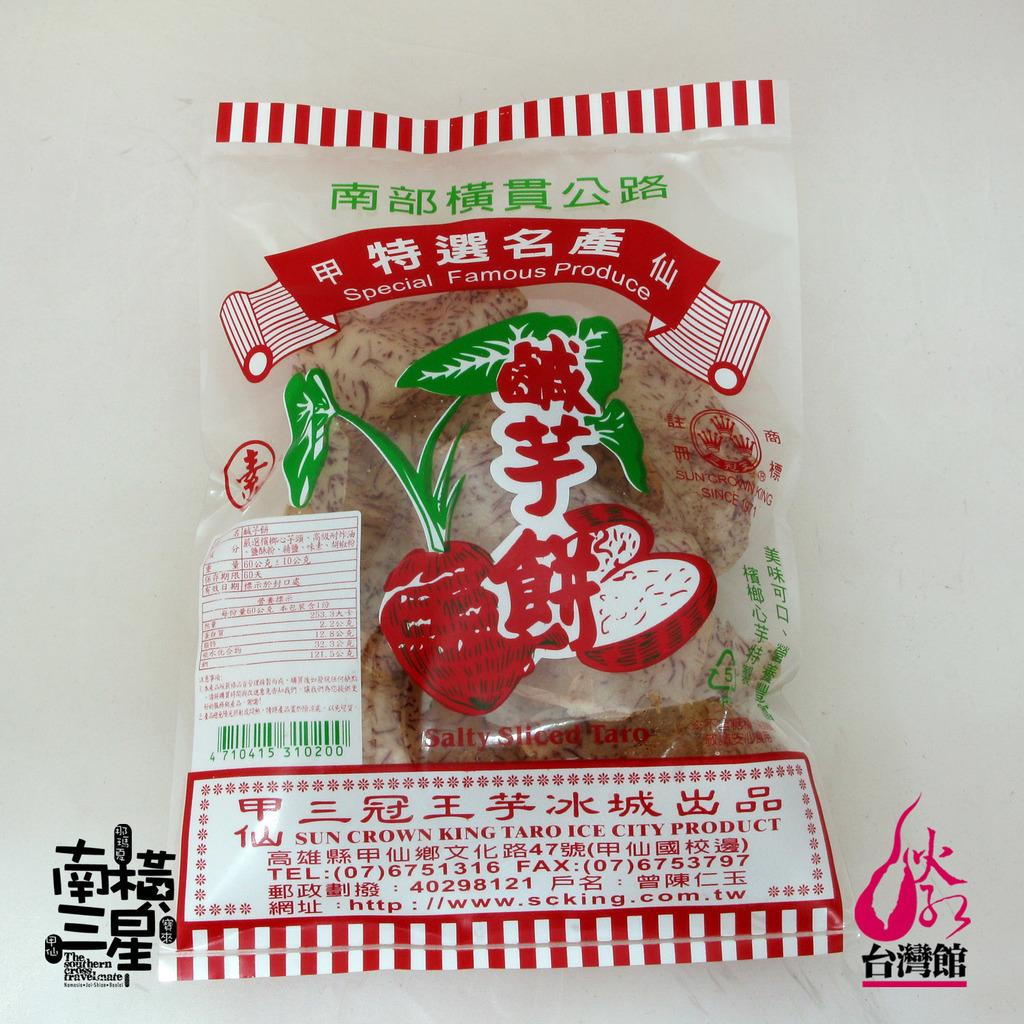What is contained within the cover in the image? There is food packed in a cover in the image. What can be seen at the bottom portion of the image? There are watermarks at the bottom portion of the image. What additional details are provided on the cover? There is information written on the cover. Can you see any ocean waves in the image? There is no ocean or waves present in the image. Is there any indication of a vacation destination in the image? There is no reference to a vacation destination in the image. 